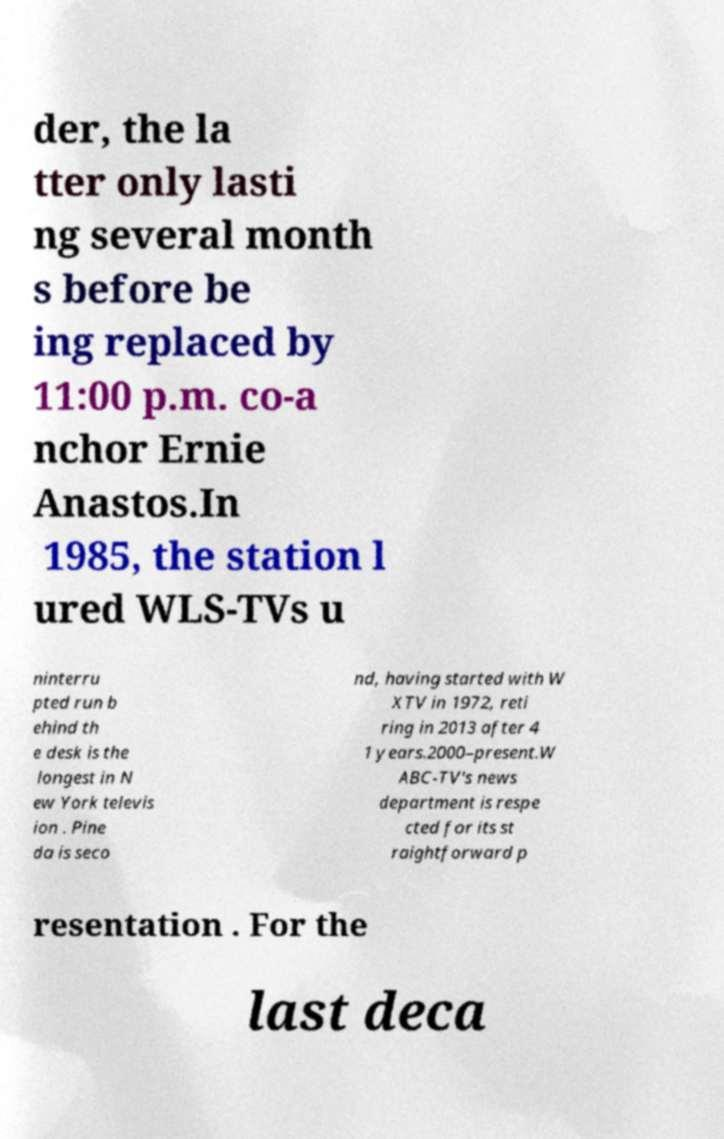Please identify and transcribe the text found in this image. der, the la tter only lasti ng several month s before be ing replaced by 11:00 p.m. co-a nchor Ernie Anastos.In 1985, the station l ured WLS-TVs u ninterru pted run b ehind th e desk is the longest in N ew York televis ion . Pine da is seco nd, having started with W XTV in 1972, reti ring in 2013 after 4 1 years.2000–present.W ABC-TV's news department is respe cted for its st raightforward p resentation . For the last deca 